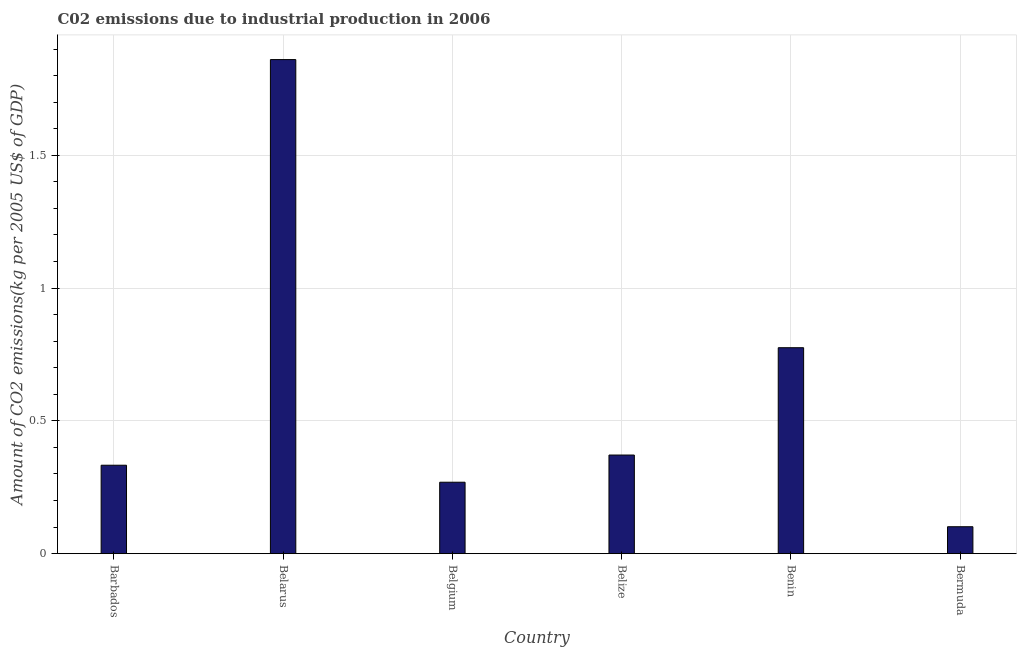Does the graph contain any zero values?
Provide a short and direct response. No. Does the graph contain grids?
Provide a succinct answer. Yes. What is the title of the graph?
Offer a terse response. C02 emissions due to industrial production in 2006. What is the label or title of the X-axis?
Offer a very short reply. Country. What is the label or title of the Y-axis?
Your answer should be compact. Amount of CO2 emissions(kg per 2005 US$ of GDP). What is the amount of co2 emissions in Benin?
Make the answer very short. 0.78. Across all countries, what is the maximum amount of co2 emissions?
Provide a short and direct response. 1.86. Across all countries, what is the minimum amount of co2 emissions?
Make the answer very short. 0.1. In which country was the amount of co2 emissions maximum?
Your answer should be compact. Belarus. In which country was the amount of co2 emissions minimum?
Your answer should be very brief. Bermuda. What is the sum of the amount of co2 emissions?
Keep it short and to the point. 3.71. What is the difference between the amount of co2 emissions in Belarus and Belize?
Make the answer very short. 1.49. What is the average amount of co2 emissions per country?
Make the answer very short. 0.62. What is the median amount of co2 emissions?
Your answer should be very brief. 0.35. In how many countries, is the amount of co2 emissions greater than 1.7 kg per 2005 US$ of GDP?
Give a very brief answer. 1. What is the ratio of the amount of co2 emissions in Belarus to that in Belize?
Give a very brief answer. 5.01. Is the amount of co2 emissions in Belize less than that in Bermuda?
Provide a succinct answer. No. What is the difference between the highest and the second highest amount of co2 emissions?
Offer a very short reply. 1.08. What is the difference between the highest and the lowest amount of co2 emissions?
Make the answer very short. 1.76. Are all the bars in the graph horizontal?
Offer a terse response. No. How many countries are there in the graph?
Provide a short and direct response. 6. What is the difference between two consecutive major ticks on the Y-axis?
Provide a short and direct response. 0.5. What is the Amount of CO2 emissions(kg per 2005 US$ of GDP) of Barbados?
Offer a very short reply. 0.33. What is the Amount of CO2 emissions(kg per 2005 US$ of GDP) of Belarus?
Your answer should be compact. 1.86. What is the Amount of CO2 emissions(kg per 2005 US$ of GDP) of Belgium?
Keep it short and to the point. 0.27. What is the Amount of CO2 emissions(kg per 2005 US$ of GDP) of Belize?
Give a very brief answer. 0.37. What is the Amount of CO2 emissions(kg per 2005 US$ of GDP) in Benin?
Offer a terse response. 0.78. What is the Amount of CO2 emissions(kg per 2005 US$ of GDP) in Bermuda?
Provide a succinct answer. 0.1. What is the difference between the Amount of CO2 emissions(kg per 2005 US$ of GDP) in Barbados and Belarus?
Offer a terse response. -1.53. What is the difference between the Amount of CO2 emissions(kg per 2005 US$ of GDP) in Barbados and Belgium?
Make the answer very short. 0.06. What is the difference between the Amount of CO2 emissions(kg per 2005 US$ of GDP) in Barbados and Belize?
Provide a succinct answer. -0.04. What is the difference between the Amount of CO2 emissions(kg per 2005 US$ of GDP) in Barbados and Benin?
Offer a very short reply. -0.44. What is the difference between the Amount of CO2 emissions(kg per 2005 US$ of GDP) in Barbados and Bermuda?
Your answer should be very brief. 0.23. What is the difference between the Amount of CO2 emissions(kg per 2005 US$ of GDP) in Belarus and Belgium?
Offer a terse response. 1.59. What is the difference between the Amount of CO2 emissions(kg per 2005 US$ of GDP) in Belarus and Belize?
Make the answer very short. 1.49. What is the difference between the Amount of CO2 emissions(kg per 2005 US$ of GDP) in Belarus and Benin?
Offer a very short reply. 1.09. What is the difference between the Amount of CO2 emissions(kg per 2005 US$ of GDP) in Belarus and Bermuda?
Make the answer very short. 1.76. What is the difference between the Amount of CO2 emissions(kg per 2005 US$ of GDP) in Belgium and Belize?
Offer a terse response. -0.1. What is the difference between the Amount of CO2 emissions(kg per 2005 US$ of GDP) in Belgium and Benin?
Your answer should be very brief. -0.51. What is the difference between the Amount of CO2 emissions(kg per 2005 US$ of GDP) in Belgium and Bermuda?
Ensure brevity in your answer.  0.17. What is the difference between the Amount of CO2 emissions(kg per 2005 US$ of GDP) in Belize and Benin?
Your response must be concise. -0.4. What is the difference between the Amount of CO2 emissions(kg per 2005 US$ of GDP) in Belize and Bermuda?
Offer a very short reply. 0.27. What is the difference between the Amount of CO2 emissions(kg per 2005 US$ of GDP) in Benin and Bermuda?
Provide a short and direct response. 0.67. What is the ratio of the Amount of CO2 emissions(kg per 2005 US$ of GDP) in Barbados to that in Belarus?
Your response must be concise. 0.18. What is the ratio of the Amount of CO2 emissions(kg per 2005 US$ of GDP) in Barbados to that in Belgium?
Your answer should be compact. 1.24. What is the ratio of the Amount of CO2 emissions(kg per 2005 US$ of GDP) in Barbados to that in Belize?
Provide a succinct answer. 0.9. What is the ratio of the Amount of CO2 emissions(kg per 2005 US$ of GDP) in Barbados to that in Benin?
Your answer should be compact. 0.43. What is the ratio of the Amount of CO2 emissions(kg per 2005 US$ of GDP) in Barbados to that in Bermuda?
Offer a very short reply. 3.29. What is the ratio of the Amount of CO2 emissions(kg per 2005 US$ of GDP) in Belarus to that in Belgium?
Make the answer very short. 6.92. What is the ratio of the Amount of CO2 emissions(kg per 2005 US$ of GDP) in Belarus to that in Belize?
Provide a succinct answer. 5.01. What is the ratio of the Amount of CO2 emissions(kg per 2005 US$ of GDP) in Belarus to that in Benin?
Give a very brief answer. 2.4. What is the ratio of the Amount of CO2 emissions(kg per 2005 US$ of GDP) in Belarus to that in Bermuda?
Give a very brief answer. 18.36. What is the ratio of the Amount of CO2 emissions(kg per 2005 US$ of GDP) in Belgium to that in Belize?
Offer a terse response. 0.72. What is the ratio of the Amount of CO2 emissions(kg per 2005 US$ of GDP) in Belgium to that in Benin?
Provide a succinct answer. 0.35. What is the ratio of the Amount of CO2 emissions(kg per 2005 US$ of GDP) in Belgium to that in Bermuda?
Your response must be concise. 2.65. What is the ratio of the Amount of CO2 emissions(kg per 2005 US$ of GDP) in Belize to that in Benin?
Offer a very short reply. 0.48. What is the ratio of the Amount of CO2 emissions(kg per 2005 US$ of GDP) in Belize to that in Bermuda?
Your answer should be compact. 3.66. What is the ratio of the Amount of CO2 emissions(kg per 2005 US$ of GDP) in Benin to that in Bermuda?
Your answer should be very brief. 7.65. 